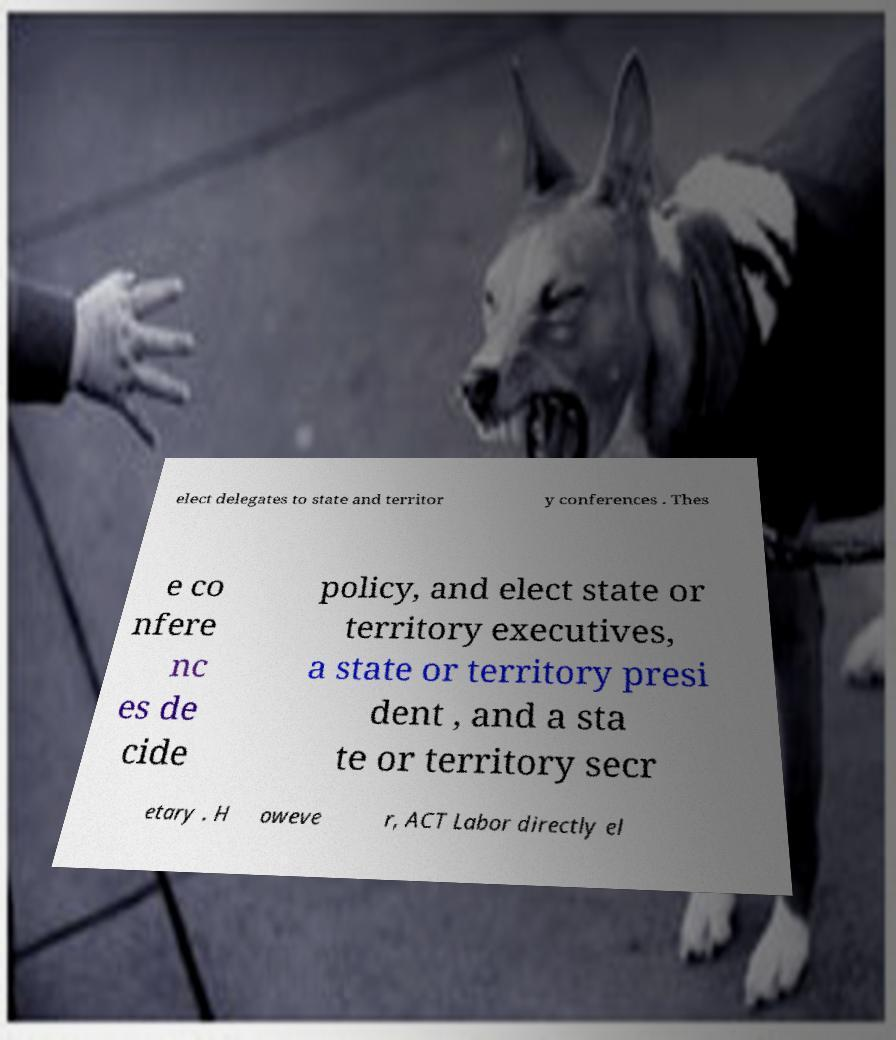Can you accurately transcribe the text from the provided image for me? elect delegates to state and territor y conferences . Thes e co nfere nc es de cide policy, and elect state or territory executives, a state or territory presi dent , and a sta te or territory secr etary . H oweve r, ACT Labor directly el 